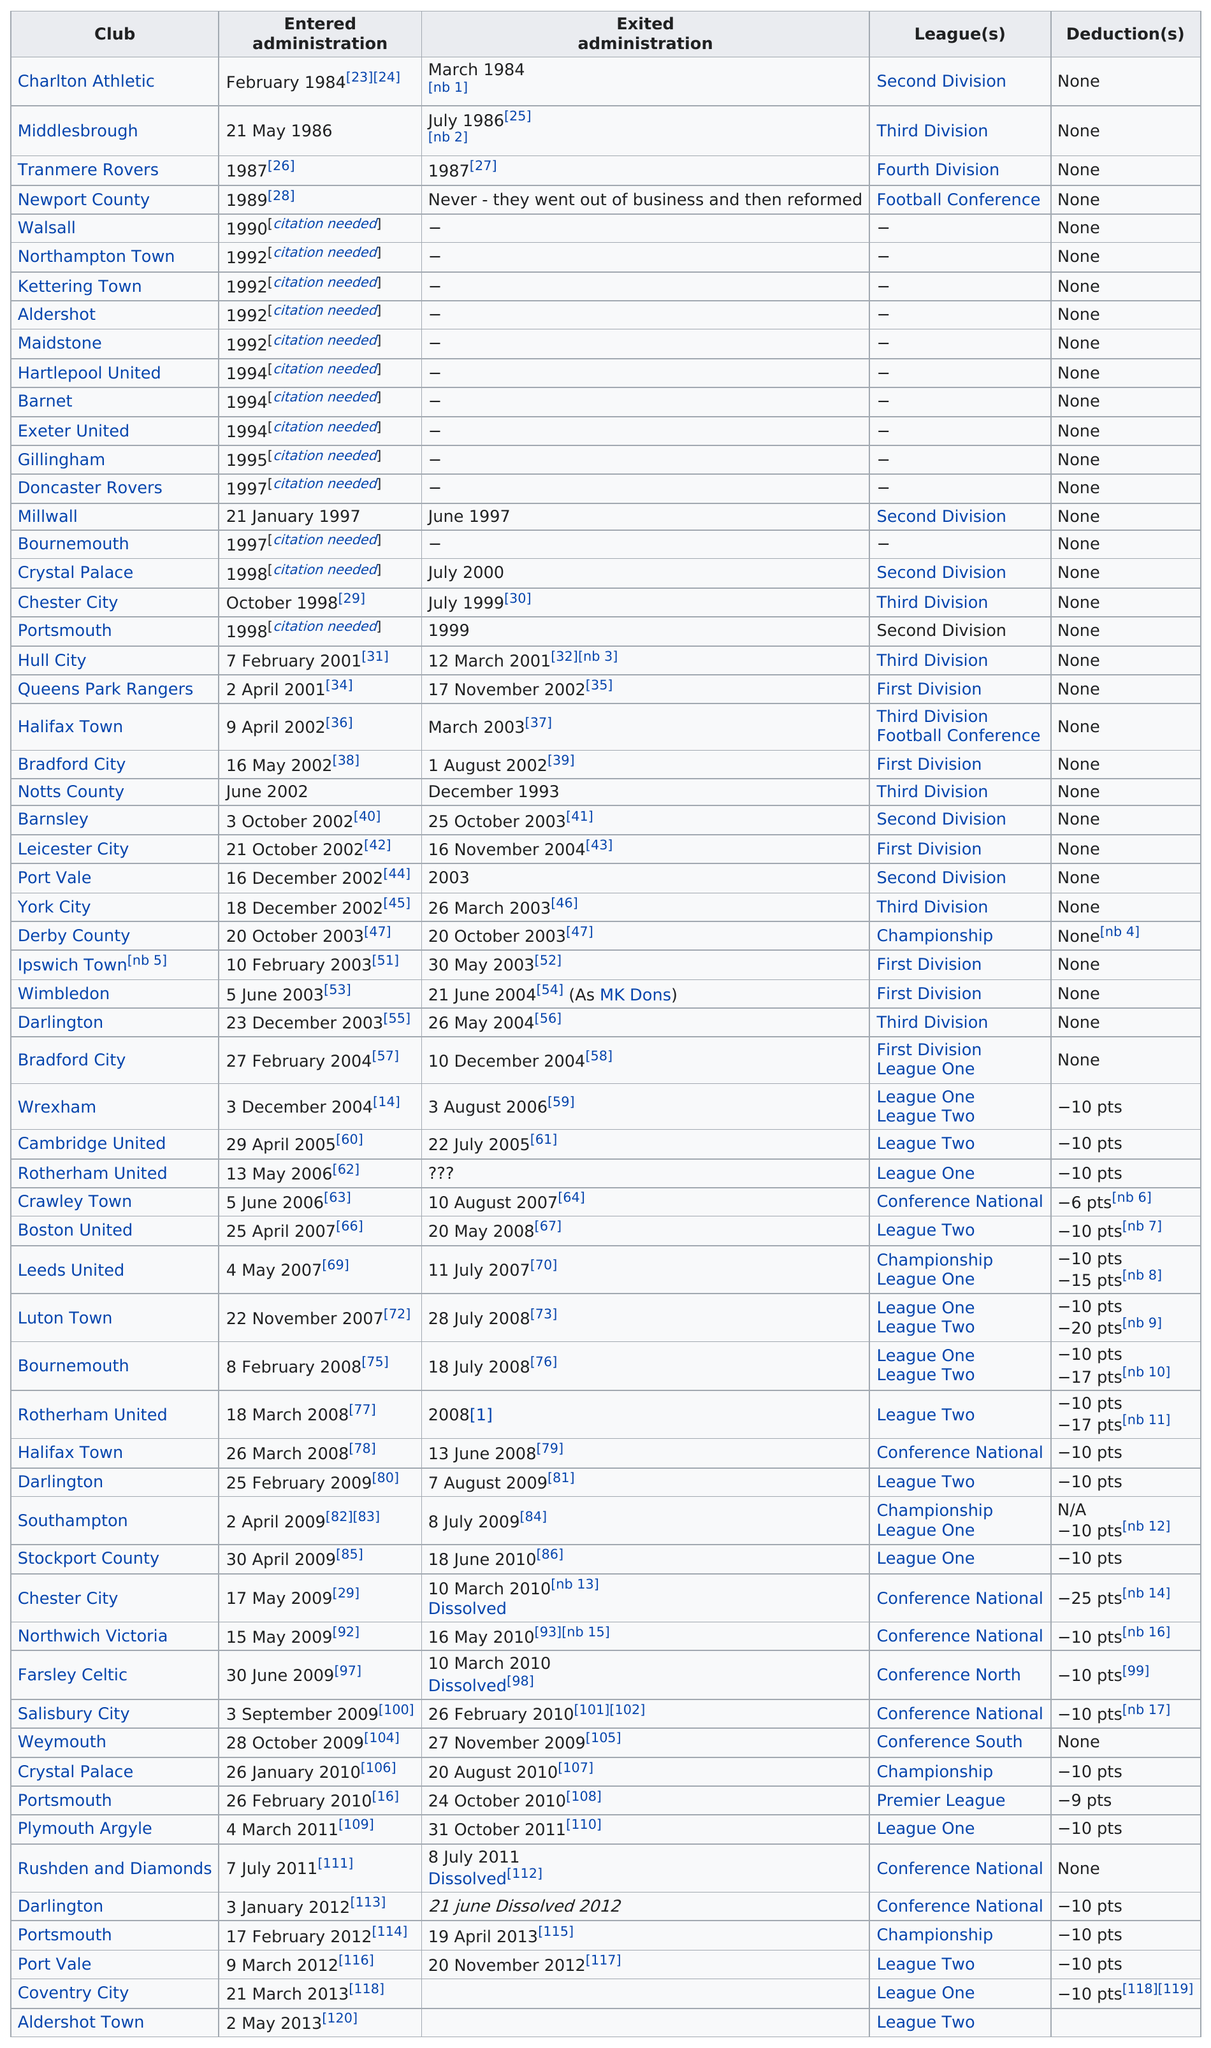Mention a couple of crucial points in this snapshot. Of the clubs that have a point differential of less than or equal to -10, how many have a higher number of wins than losses? Twenty-four teams have received deductions thus far. Before 2004, 32 teams entered administration. Charlton Athletic is the football team that spent the least amount of time in the administration, demonstrating their exceptional performance and efficient management. For one month, Charlton Athletic was in administration. 